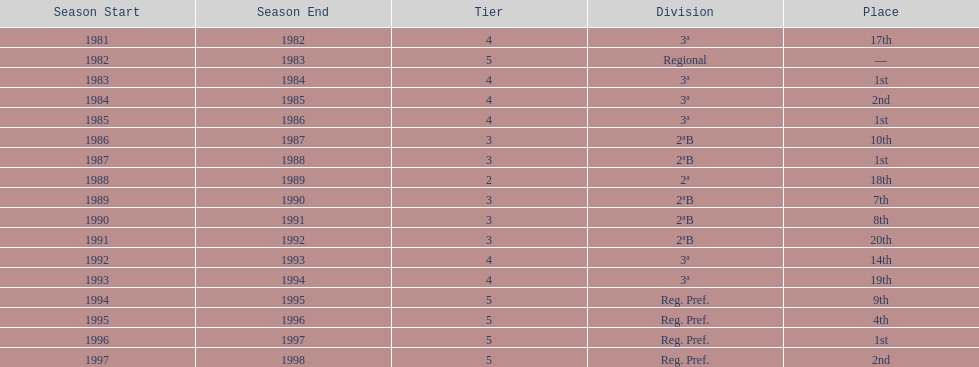When is the last year that the team has been division 2? 1991/92. 